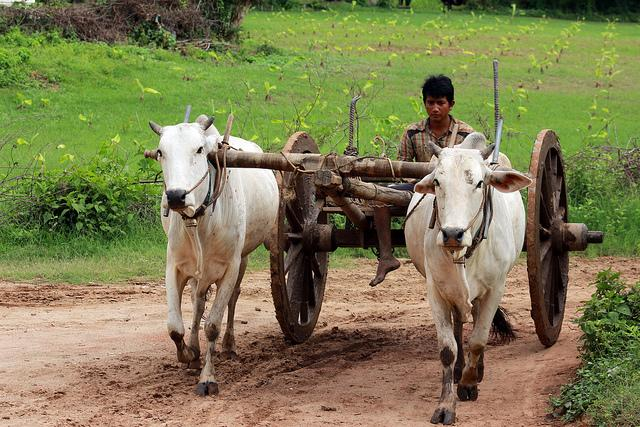What kind of animal is the cart pulled by?

Choices:
A) goat
B) ox
C) cow
D) horse ox 